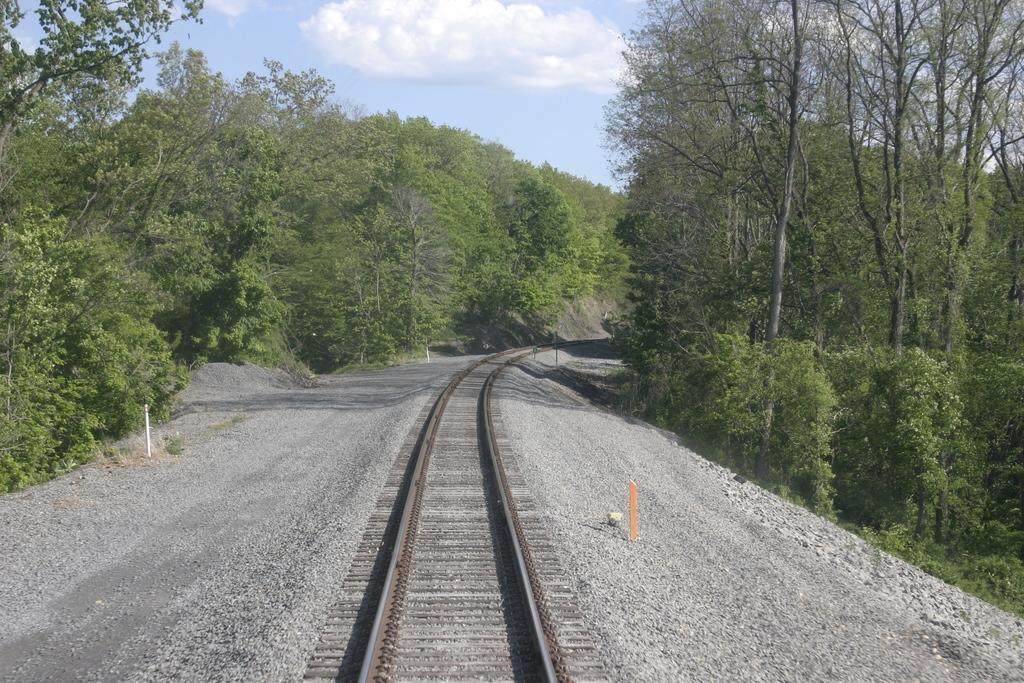Please provide a concise description of this image. In this image we can a railway track. In the background we can see group of trees and sky. 